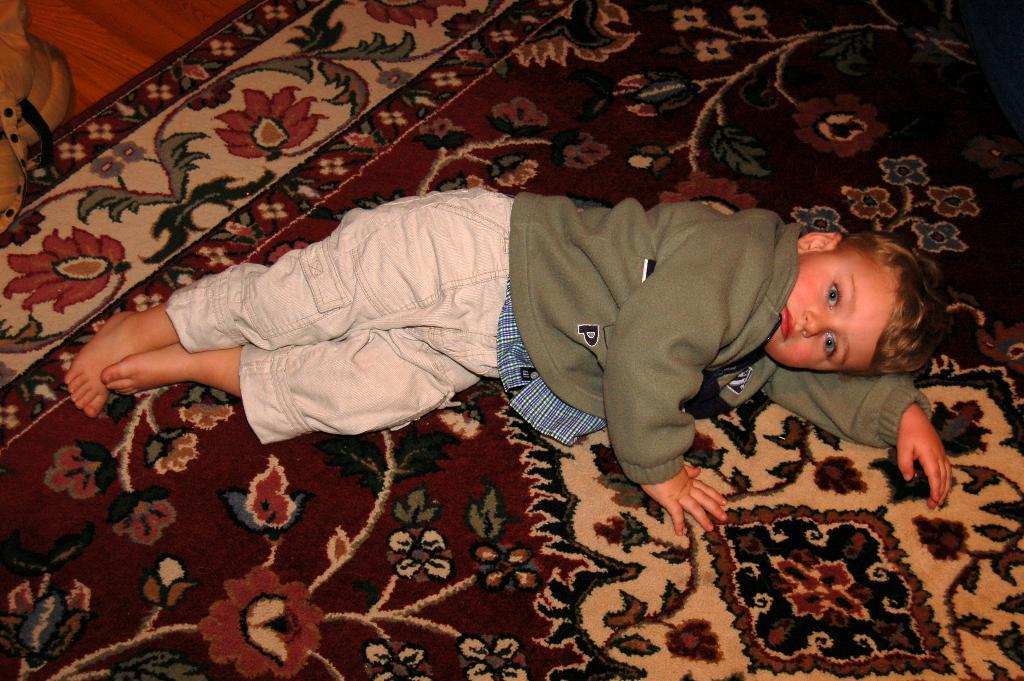Who is the main subject in the image? There is a boy in the image. What is the boy doing in the image? The boy is lying on a floor mat. Can you describe the object in the top left corner of the image? Unfortunately, the facts provided do not give any information about the object in the top left corner of the image. What type of brain can be seen in the image? There is no brain present in the image. Can you describe the face of the boy in the image? The facts provided do not give any information about the boy's face, so we cannot describe it. 